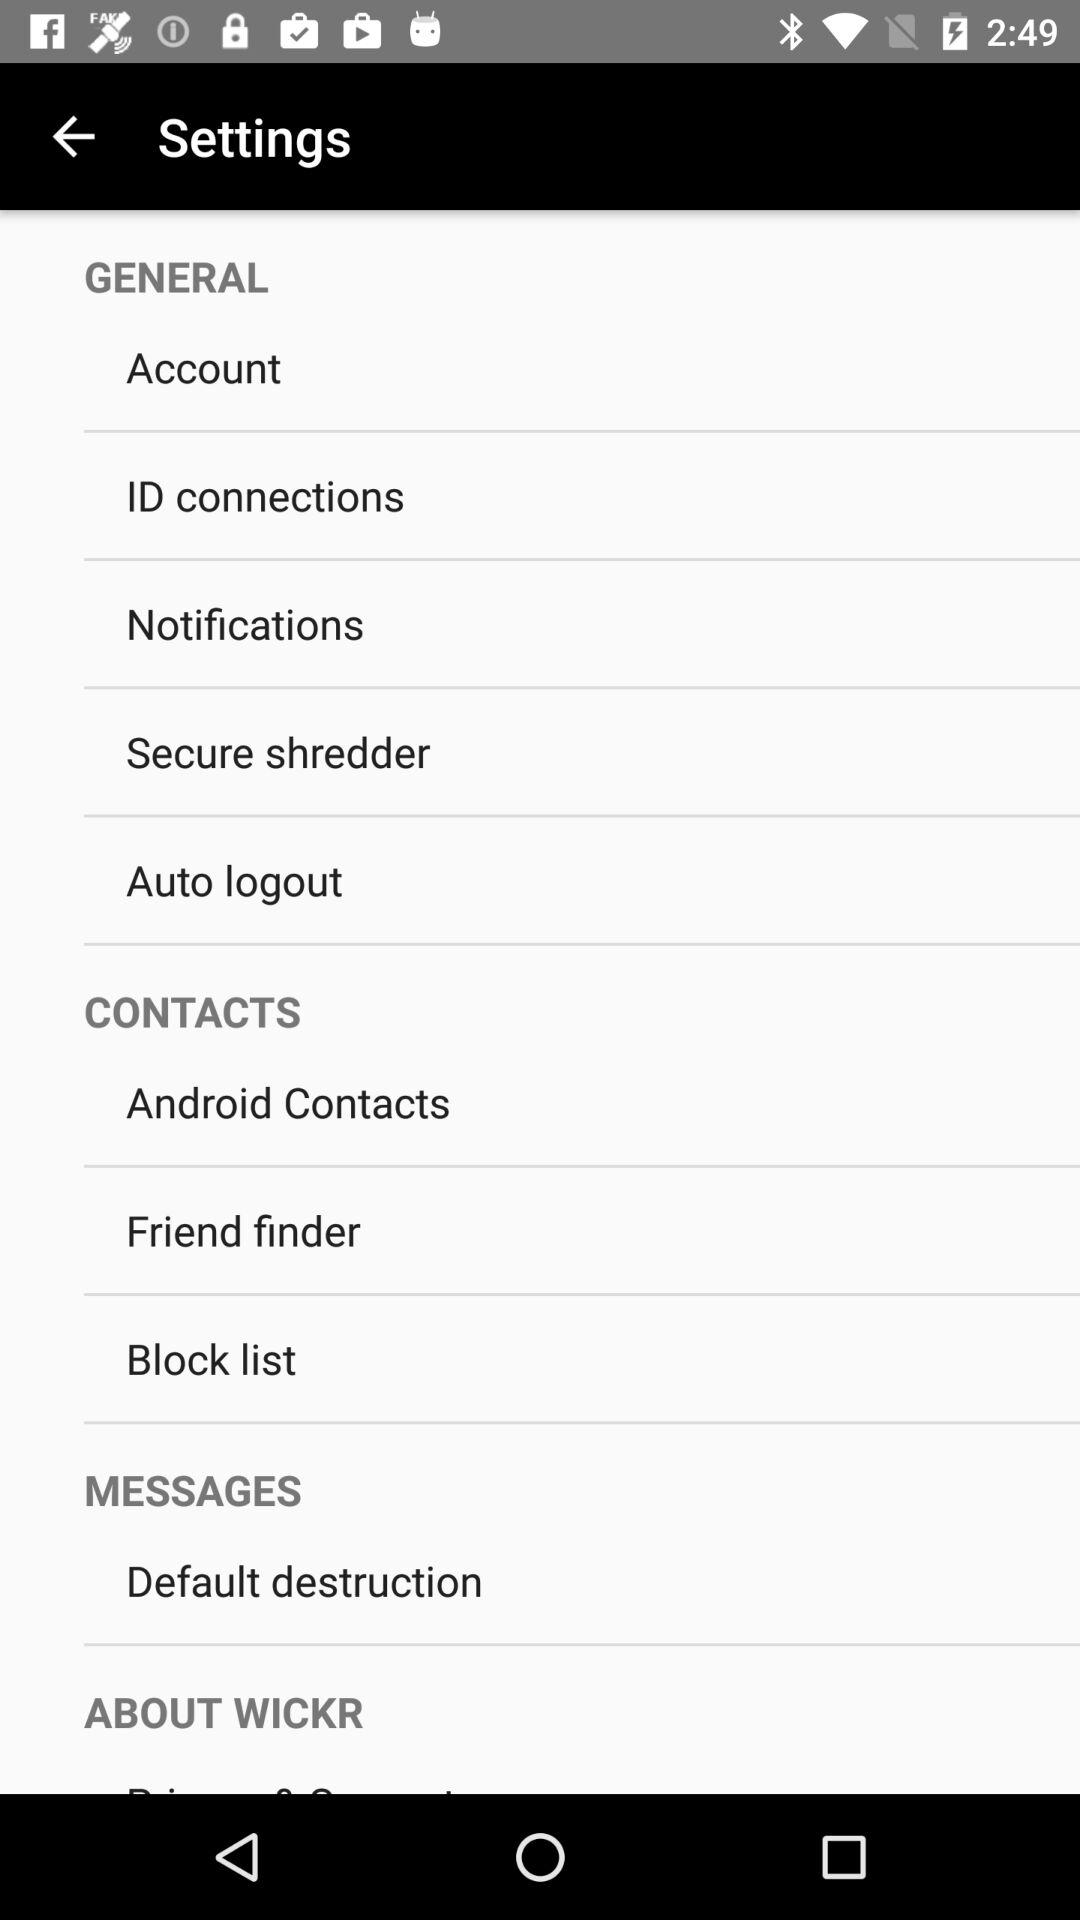How many items are in the general section?
Answer the question using a single word or phrase. 5 